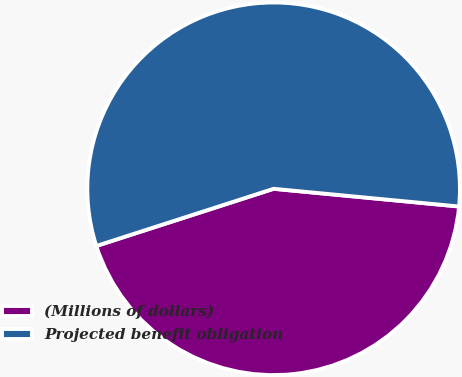<chart> <loc_0><loc_0><loc_500><loc_500><pie_chart><fcel>(Millions of dollars)<fcel>Projected benefit obligation<nl><fcel>43.52%<fcel>56.48%<nl></chart> 